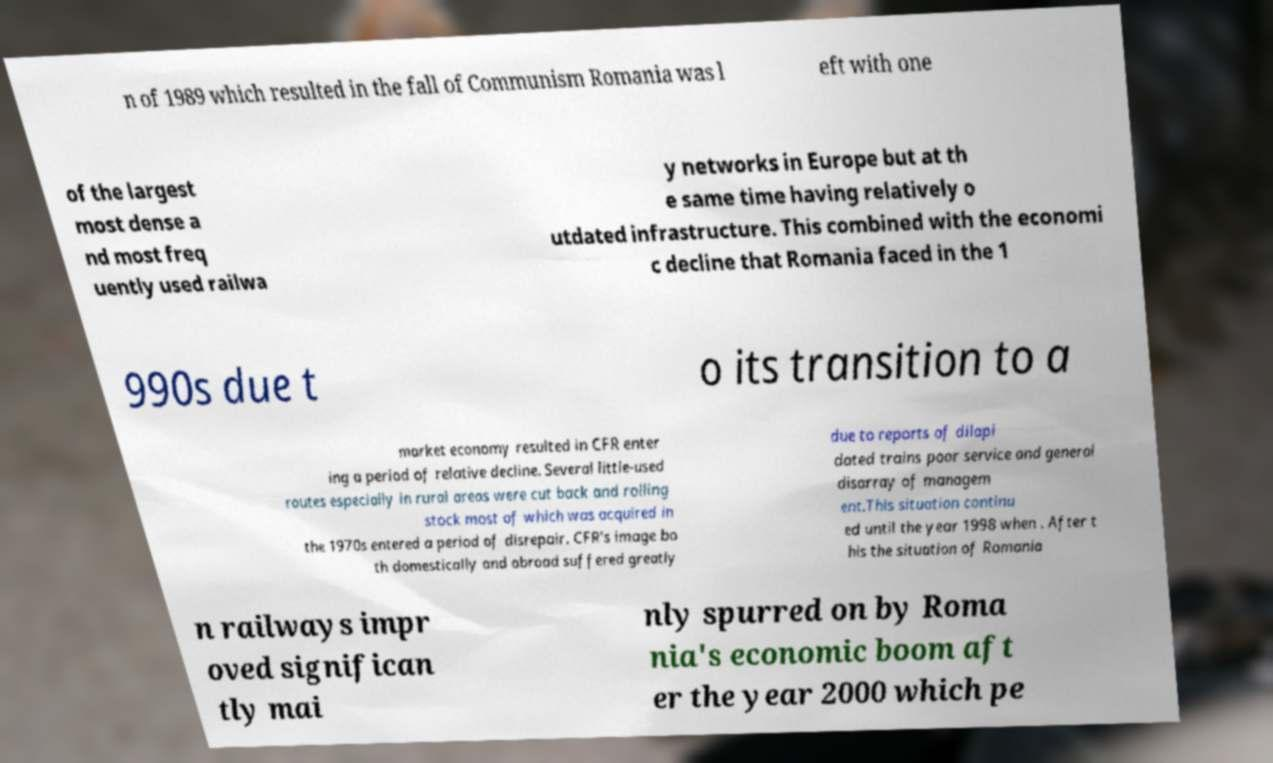I need the written content from this picture converted into text. Can you do that? n of 1989 which resulted in the fall of Communism Romania was l eft with one of the largest most dense a nd most freq uently used railwa y networks in Europe but at th e same time having relatively o utdated infrastructure. This combined with the economi c decline that Romania faced in the 1 990s due t o its transition to a market economy resulted in CFR enter ing a period of relative decline. Several little-used routes especially in rural areas were cut back and rolling stock most of which was acquired in the 1970s entered a period of disrepair. CFR's image bo th domestically and abroad suffered greatly due to reports of dilapi dated trains poor service and general disarray of managem ent.This situation continu ed until the year 1998 when . After t his the situation of Romania n railways impr oved significan tly mai nly spurred on by Roma nia's economic boom aft er the year 2000 which pe 